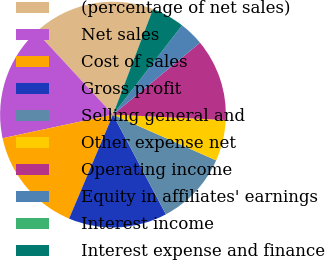Convert chart. <chart><loc_0><loc_0><loc_500><loc_500><pie_chart><fcel>(percentage of net sales)<fcel>Net sales<fcel>Cost of sales<fcel>Gross profit<fcel>Selling general and<fcel>Other expense net<fcel>Operating income<fcel>Equity in affiliates' earnings<fcel>Interest income<fcel>Interest expense and finance<nl><fcel>17.65%<fcel>16.47%<fcel>15.29%<fcel>14.12%<fcel>10.59%<fcel>5.88%<fcel>11.76%<fcel>3.53%<fcel>0.0%<fcel>4.71%<nl></chart> 